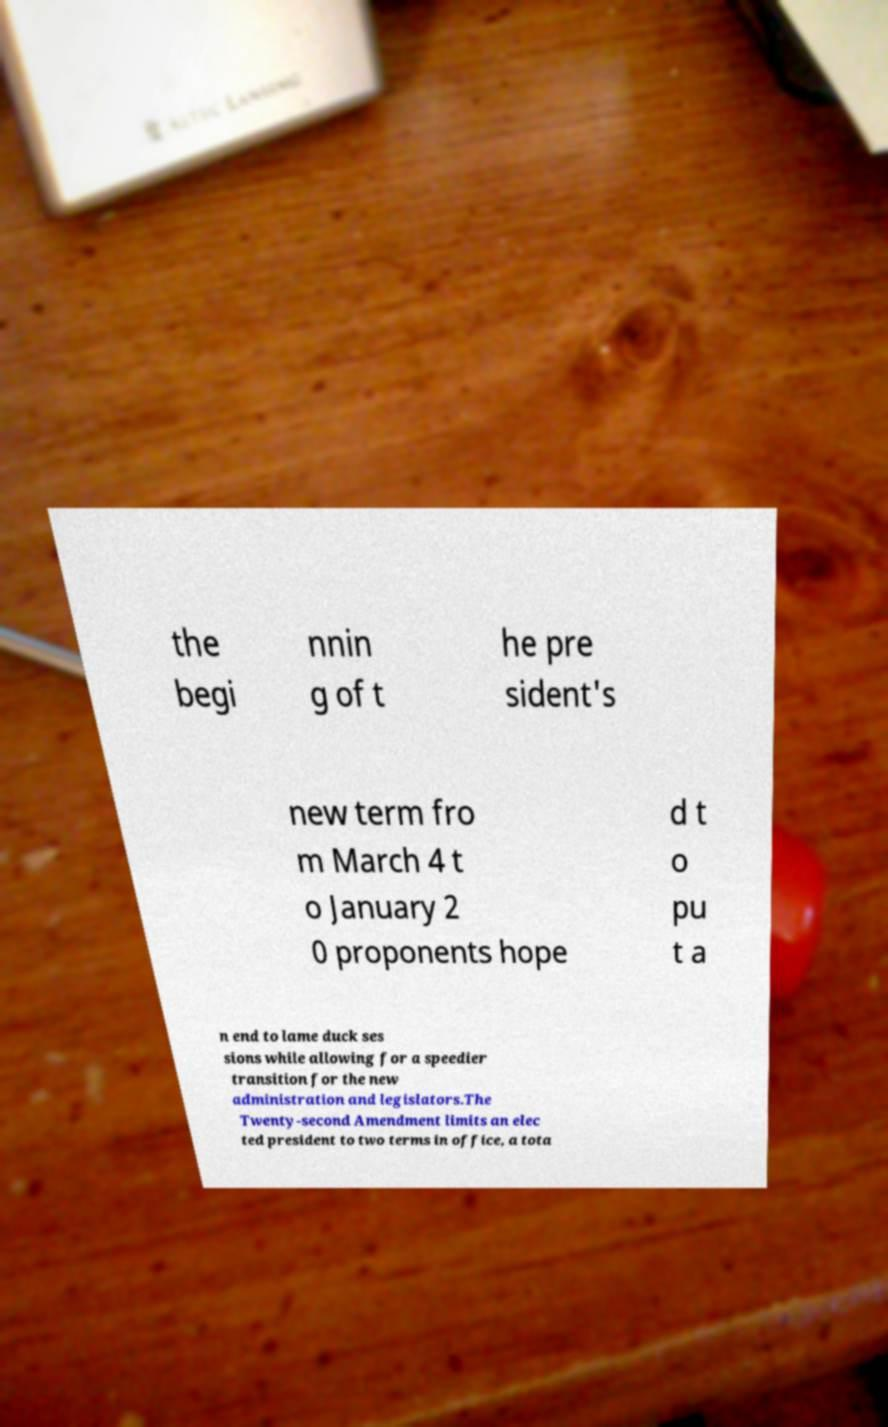What messages or text are displayed in this image? I need them in a readable, typed format. the begi nnin g of t he pre sident's new term fro m March 4 t o January 2 0 proponents hope d t o pu t a n end to lame duck ses sions while allowing for a speedier transition for the new administration and legislators.The Twenty-second Amendment limits an elec ted president to two terms in office, a tota 